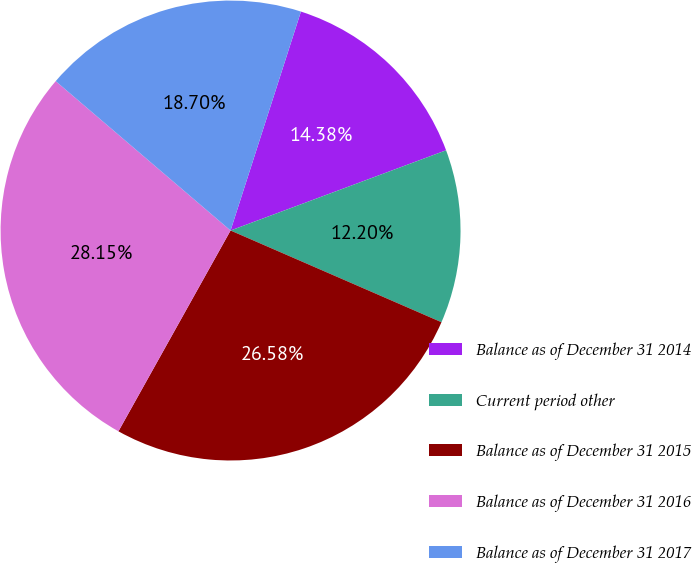Convert chart. <chart><loc_0><loc_0><loc_500><loc_500><pie_chart><fcel>Balance as of December 31 2014<fcel>Current period other<fcel>Balance as of December 31 2015<fcel>Balance as of December 31 2016<fcel>Balance as of December 31 2017<nl><fcel>14.38%<fcel>12.2%<fcel>26.58%<fcel>28.15%<fcel>18.7%<nl></chart> 